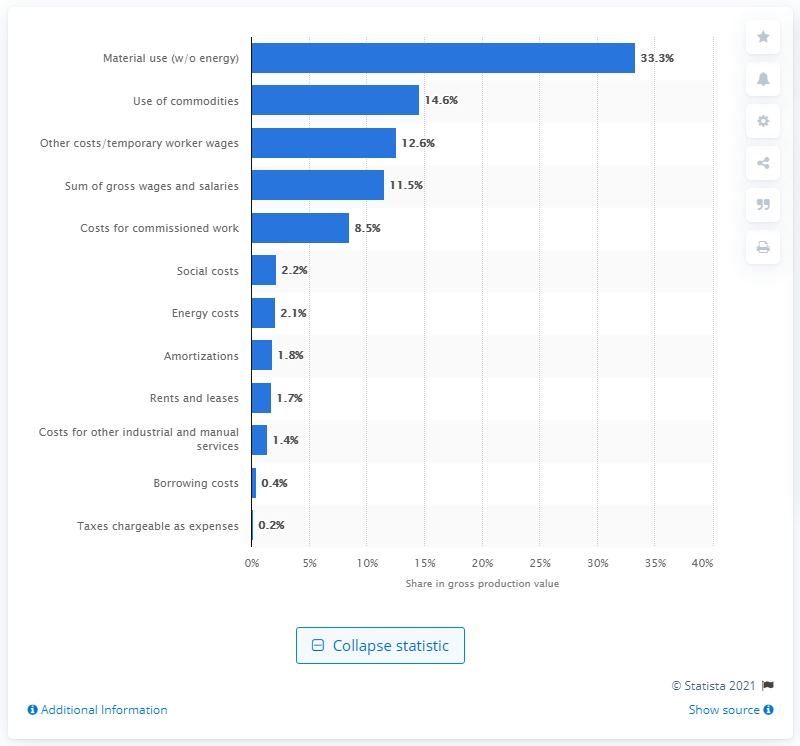Specify some key components in this picture. In 2016, the share of gross wages and salaries in the gross production value of the German ice cream production industry was 11.5%. 